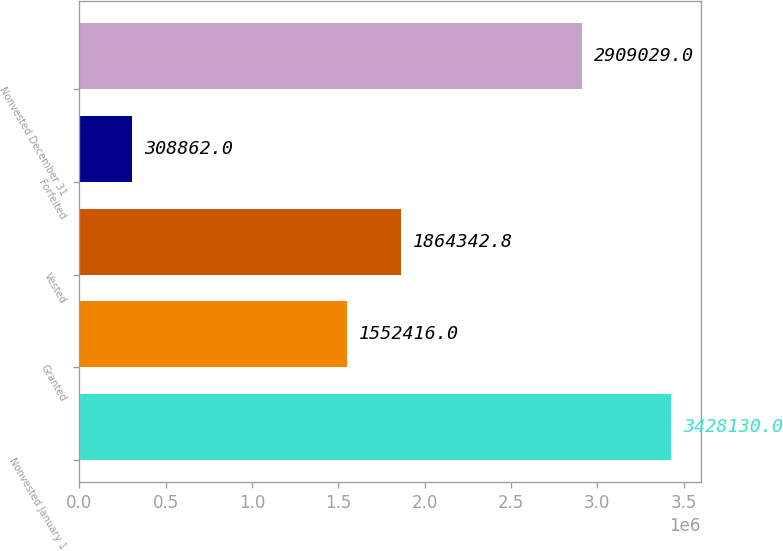Convert chart. <chart><loc_0><loc_0><loc_500><loc_500><bar_chart><fcel>Nonvested January 1<fcel>Granted<fcel>Vested<fcel>Forfeited<fcel>Nonvested December 31<nl><fcel>3.42813e+06<fcel>1.55242e+06<fcel>1.86434e+06<fcel>308862<fcel>2.90903e+06<nl></chart> 